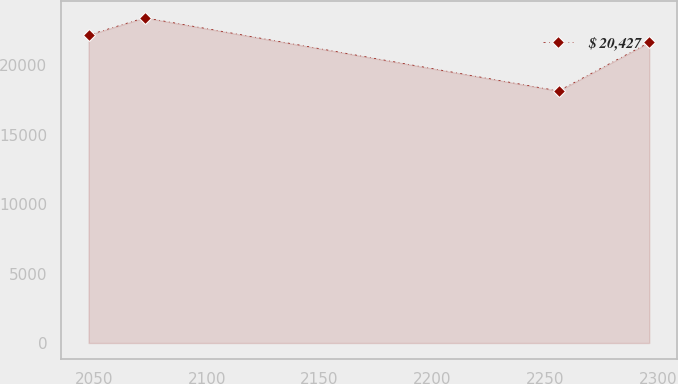Convert chart to OTSL. <chart><loc_0><loc_0><loc_500><loc_500><line_chart><ecel><fcel>$ 20,427<nl><fcel>2047.68<fcel>22181.8<nl><fcel>2072.53<fcel>23436.2<nl><fcel>2255.94<fcel>18159.2<nl><fcel>2296.15<fcel>21654.1<nl></chart> 